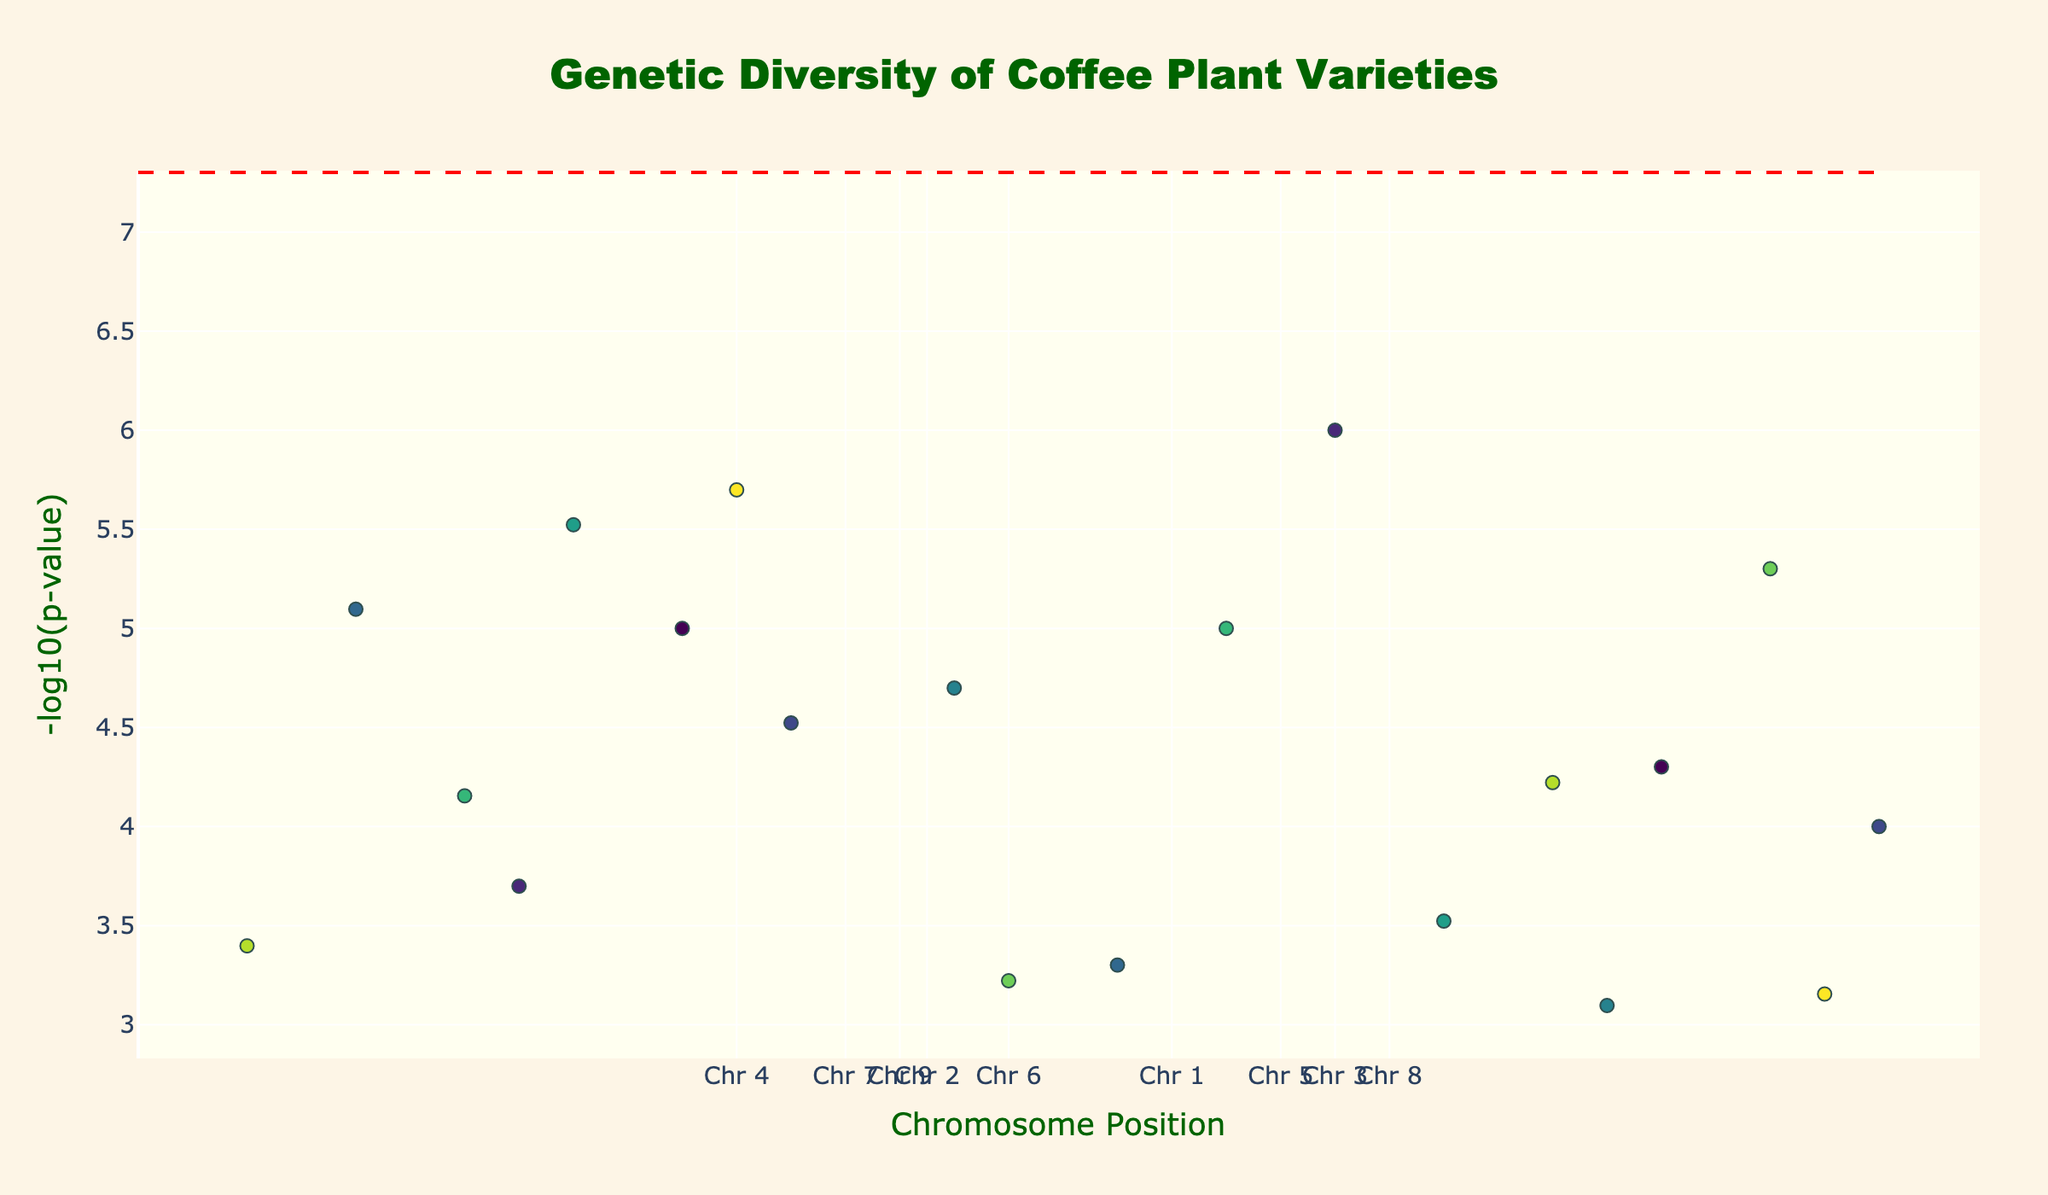What's the title of the plot? The title is located at the top center of the plot in the largest font size.
Answer: Genetic Diversity of Coffee Plant Varieties What are the units on the x-axis? The x-axis represents the chromosome positions, each tick labeled as 'Chr' followed by a number from 1 to 10.
Answer: Chromosome Position What coffee variety corresponds to the smallest p-value? The variety with the smallest p-value will have the highest -log10(p-value) value, located highest on the y-axis of the plot.
Answer: Gesha Which coffee variety is located at the 3rd chromosome's 40,000,000 position? Look for the marker plotted at the 40,000,000 position along the x-axis for chromosome 3; check the hover text or legend to identify the coffee variety.
Answer: SL28 How many coffee varieties have a -log10(p-value) greater than 4? Identify data points with y-values above 4; count these points.
Answer: 8 What is the range of chromosome positions presented in the plot? Check the minimum and maximum values on the x-axis ticks, from the start of chromosome 1 to the end of chromosome 10.
Answer: 0 to 40,000,000 Which chromosome has the highest average -log10(p-value)? Group data points by chromosome, calculate the average -log10(p-value) for each, and compare.
Answer: Chromosome 6 Is the significance threshold line crossed by any data points? The significance threshold line is a horizontal dashed line. Identify if any data points are plotted above this line.
Answer: Yes What is the unique color scheme used for different chromosomes? Different colors (a colorscale like 'Viridis') are used to distinguish chromosomes, which is evident by the varying colors of the markers.
Answer: Viridis Which coffee variety exhibits a p-value around 0.00007? Calculate -log10(0.00007) and find the closest data point on the y-axis matching this approximate value.
Answer: Tabi 